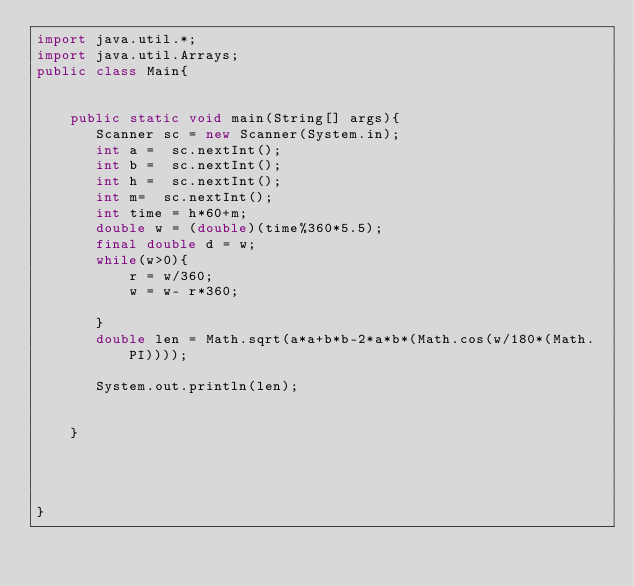<code> <loc_0><loc_0><loc_500><loc_500><_Java_>import java.util.*;
import java.util.Arrays;
public class Main{
    
    
    public static void main(String[] args){
       Scanner sc = new Scanner(System.in);
       int a =  sc.nextInt();
       int b =  sc.nextInt();
       int h =  sc.nextInt();
       int m=  sc.nextInt();
       int time = h*60+m;
       double w = (double)(time%360*5.5);
       final double d = w;
       while(w>0){
           r = w/360;
           w = w- r*360;

       }
       double len = Math.sqrt(a*a+b*b-2*a*b*(Math.cos(w/180*(Math.PI))));
    
       System.out.println(len);

       
    }
   
    
       
    
}</code> 